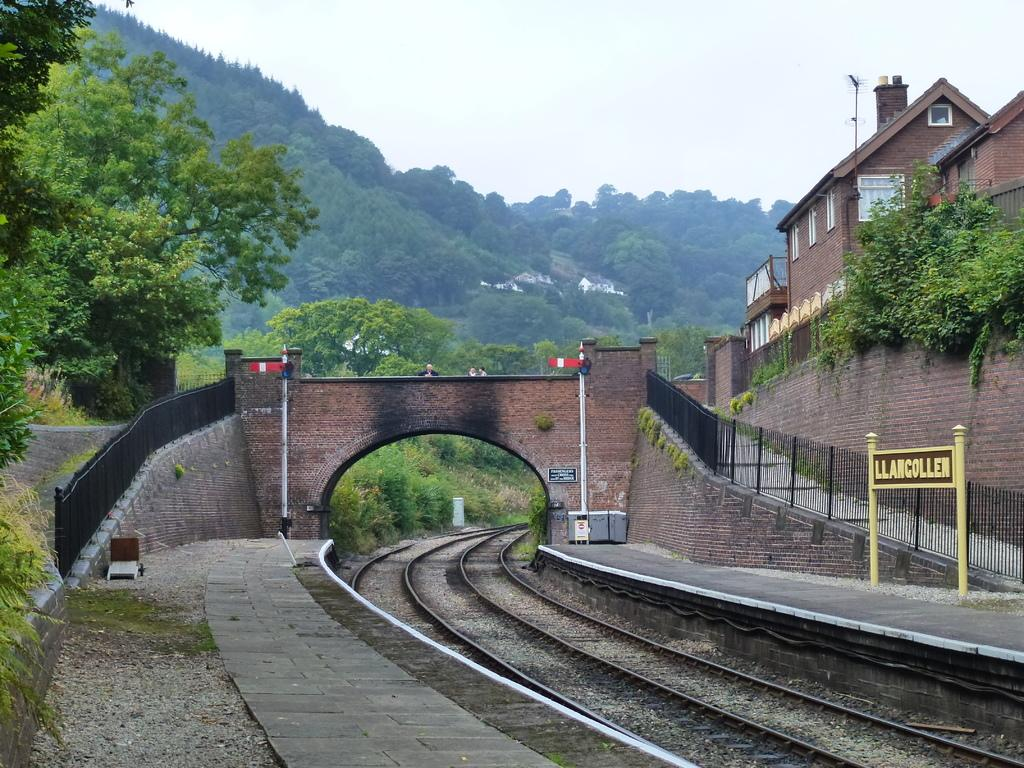<image>
Summarize the visual content of the image. Train tracks go under a brick bridge in LLANCOLLEN. 